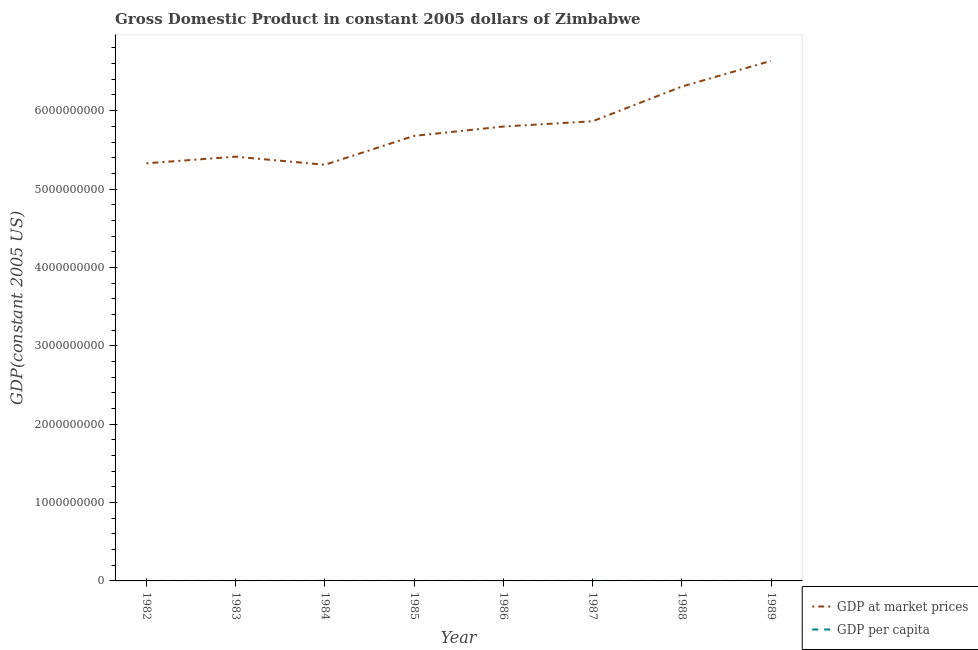What is the gdp per capita in 1984?
Keep it short and to the point. 622.59. Across all years, what is the maximum gdp per capita?
Your answer should be compact. 676.51. Across all years, what is the minimum gdp per capita?
Provide a succinct answer. 614.99. In which year was the gdp per capita maximum?
Your answer should be very brief. 1982. In which year was the gdp at market prices minimum?
Provide a short and direct response. 1984. What is the total gdp at market prices in the graph?
Your answer should be compact. 4.63e+1. What is the difference between the gdp at market prices in 1984 and that in 1985?
Your answer should be compact. -3.69e+08. What is the difference between the gdp per capita in 1988 and the gdp at market prices in 1987?
Provide a short and direct response. -5.86e+09. What is the average gdp at market prices per year?
Your answer should be compact. 5.79e+09. In the year 1984, what is the difference between the gdp per capita and gdp at market prices?
Give a very brief answer. -5.31e+09. In how many years, is the gdp per capita greater than 5600000000 US$?
Make the answer very short. 0. What is the ratio of the gdp per capita in 1983 to that in 1984?
Offer a very short reply. 1.06. Is the gdp at market prices in 1983 less than that in 1986?
Provide a short and direct response. Yes. Is the difference between the gdp at market prices in 1984 and 1988 greater than the difference between the gdp per capita in 1984 and 1988?
Your answer should be compact. No. What is the difference between the highest and the second highest gdp per capita?
Ensure brevity in your answer.  16.2. What is the difference between the highest and the lowest gdp per capita?
Give a very brief answer. 61.52. In how many years, is the gdp at market prices greater than the average gdp at market prices taken over all years?
Your answer should be compact. 4. Does the gdp at market prices monotonically increase over the years?
Your answer should be very brief. No. Is the gdp at market prices strictly greater than the gdp per capita over the years?
Offer a very short reply. Yes. Is the gdp at market prices strictly less than the gdp per capita over the years?
Offer a very short reply. No. How many years are there in the graph?
Your answer should be very brief. 8. Where does the legend appear in the graph?
Your response must be concise. Bottom right. How are the legend labels stacked?
Provide a short and direct response. Vertical. What is the title of the graph?
Ensure brevity in your answer.  Gross Domestic Product in constant 2005 dollars of Zimbabwe. Does "Goods" appear as one of the legend labels in the graph?
Provide a succinct answer. No. What is the label or title of the Y-axis?
Offer a terse response. GDP(constant 2005 US). What is the GDP(constant 2005 US) in GDP at market prices in 1982?
Offer a terse response. 5.33e+09. What is the GDP(constant 2005 US) in GDP per capita in 1982?
Your answer should be very brief. 676.51. What is the GDP(constant 2005 US) in GDP at market prices in 1983?
Provide a short and direct response. 5.41e+09. What is the GDP(constant 2005 US) of GDP per capita in 1983?
Offer a terse response. 660.31. What is the GDP(constant 2005 US) in GDP at market prices in 1984?
Offer a very short reply. 5.31e+09. What is the GDP(constant 2005 US) in GDP per capita in 1984?
Your response must be concise. 622.59. What is the GDP(constant 2005 US) of GDP at market prices in 1985?
Provide a short and direct response. 5.68e+09. What is the GDP(constant 2005 US) of GDP per capita in 1985?
Give a very brief answer. 640.72. What is the GDP(constant 2005 US) in GDP at market prices in 1986?
Give a very brief answer. 5.80e+09. What is the GDP(constant 2005 US) of GDP per capita in 1986?
Your answer should be very brief. 630.25. What is the GDP(constant 2005 US) in GDP at market prices in 1987?
Your answer should be very brief. 5.86e+09. What is the GDP(constant 2005 US) in GDP per capita in 1987?
Provide a short and direct response. 614.99. What is the GDP(constant 2005 US) in GDP at market prices in 1988?
Offer a terse response. 6.31e+09. What is the GDP(constant 2005 US) of GDP per capita in 1988?
Offer a very short reply. 639.24. What is the GDP(constant 2005 US) in GDP at market prices in 1989?
Make the answer very short. 6.64e+09. What is the GDP(constant 2005 US) of GDP per capita in 1989?
Keep it short and to the point. 651.47. Across all years, what is the maximum GDP(constant 2005 US) of GDP at market prices?
Make the answer very short. 6.64e+09. Across all years, what is the maximum GDP(constant 2005 US) in GDP per capita?
Your response must be concise. 676.51. Across all years, what is the minimum GDP(constant 2005 US) of GDP at market prices?
Your answer should be very brief. 5.31e+09. Across all years, what is the minimum GDP(constant 2005 US) in GDP per capita?
Provide a short and direct response. 614.99. What is the total GDP(constant 2005 US) of GDP at market prices in the graph?
Your response must be concise. 4.63e+1. What is the total GDP(constant 2005 US) of GDP per capita in the graph?
Give a very brief answer. 5136.07. What is the difference between the GDP(constant 2005 US) in GDP at market prices in 1982 and that in 1983?
Make the answer very short. -8.45e+07. What is the difference between the GDP(constant 2005 US) in GDP per capita in 1982 and that in 1983?
Provide a succinct answer. 16.2. What is the difference between the GDP(constant 2005 US) in GDP at market prices in 1982 and that in 1984?
Your response must be concise. 1.88e+07. What is the difference between the GDP(constant 2005 US) of GDP per capita in 1982 and that in 1984?
Your response must be concise. 53.91. What is the difference between the GDP(constant 2005 US) in GDP at market prices in 1982 and that in 1985?
Offer a terse response. -3.50e+08. What is the difference between the GDP(constant 2005 US) of GDP per capita in 1982 and that in 1985?
Ensure brevity in your answer.  35.79. What is the difference between the GDP(constant 2005 US) in GDP at market prices in 1982 and that in 1986?
Your response must be concise. -4.69e+08. What is the difference between the GDP(constant 2005 US) in GDP per capita in 1982 and that in 1986?
Make the answer very short. 46.26. What is the difference between the GDP(constant 2005 US) of GDP at market prices in 1982 and that in 1987?
Your answer should be very brief. -5.36e+08. What is the difference between the GDP(constant 2005 US) of GDP per capita in 1982 and that in 1987?
Ensure brevity in your answer.  61.52. What is the difference between the GDP(constant 2005 US) of GDP at market prices in 1982 and that in 1988?
Offer a terse response. -9.79e+08. What is the difference between the GDP(constant 2005 US) of GDP per capita in 1982 and that in 1988?
Offer a terse response. 37.27. What is the difference between the GDP(constant 2005 US) in GDP at market prices in 1982 and that in 1989?
Provide a short and direct response. -1.31e+09. What is the difference between the GDP(constant 2005 US) of GDP per capita in 1982 and that in 1989?
Ensure brevity in your answer.  25.04. What is the difference between the GDP(constant 2005 US) of GDP at market prices in 1983 and that in 1984?
Your answer should be very brief. 1.03e+08. What is the difference between the GDP(constant 2005 US) of GDP per capita in 1983 and that in 1984?
Your answer should be very brief. 37.72. What is the difference between the GDP(constant 2005 US) in GDP at market prices in 1983 and that in 1985?
Your answer should be compact. -2.65e+08. What is the difference between the GDP(constant 2005 US) in GDP per capita in 1983 and that in 1985?
Offer a terse response. 19.59. What is the difference between the GDP(constant 2005 US) of GDP at market prices in 1983 and that in 1986?
Offer a very short reply. -3.85e+08. What is the difference between the GDP(constant 2005 US) of GDP per capita in 1983 and that in 1986?
Ensure brevity in your answer.  30.06. What is the difference between the GDP(constant 2005 US) in GDP at market prices in 1983 and that in 1987?
Your answer should be compact. -4.51e+08. What is the difference between the GDP(constant 2005 US) in GDP per capita in 1983 and that in 1987?
Make the answer very short. 45.32. What is the difference between the GDP(constant 2005 US) in GDP at market prices in 1983 and that in 1988?
Offer a very short reply. -8.94e+08. What is the difference between the GDP(constant 2005 US) in GDP per capita in 1983 and that in 1988?
Your answer should be very brief. 21.07. What is the difference between the GDP(constant 2005 US) in GDP at market prices in 1983 and that in 1989?
Offer a terse response. -1.22e+09. What is the difference between the GDP(constant 2005 US) in GDP per capita in 1983 and that in 1989?
Your response must be concise. 8.84. What is the difference between the GDP(constant 2005 US) of GDP at market prices in 1984 and that in 1985?
Offer a very short reply. -3.69e+08. What is the difference between the GDP(constant 2005 US) in GDP per capita in 1984 and that in 1985?
Provide a succinct answer. -18.12. What is the difference between the GDP(constant 2005 US) of GDP at market prices in 1984 and that in 1986?
Your answer should be very brief. -4.88e+08. What is the difference between the GDP(constant 2005 US) in GDP per capita in 1984 and that in 1986?
Provide a succinct answer. -7.66. What is the difference between the GDP(constant 2005 US) of GDP at market prices in 1984 and that in 1987?
Give a very brief answer. -5.55e+08. What is the difference between the GDP(constant 2005 US) in GDP per capita in 1984 and that in 1987?
Provide a succinct answer. 7.61. What is the difference between the GDP(constant 2005 US) in GDP at market prices in 1984 and that in 1988?
Your response must be concise. -9.98e+08. What is the difference between the GDP(constant 2005 US) of GDP per capita in 1984 and that in 1988?
Make the answer very short. -16.64. What is the difference between the GDP(constant 2005 US) of GDP at market prices in 1984 and that in 1989?
Your response must be concise. -1.33e+09. What is the difference between the GDP(constant 2005 US) of GDP per capita in 1984 and that in 1989?
Your response must be concise. -28.87. What is the difference between the GDP(constant 2005 US) in GDP at market prices in 1985 and that in 1986?
Ensure brevity in your answer.  -1.19e+08. What is the difference between the GDP(constant 2005 US) of GDP per capita in 1985 and that in 1986?
Your answer should be compact. 10.46. What is the difference between the GDP(constant 2005 US) in GDP at market prices in 1985 and that in 1987?
Make the answer very short. -1.86e+08. What is the difference between the GDP(constant 2005 US) of GDP per capita in 1985 and that in 1987?
Make the answer very short. 25.73. What is the difference between the GDP(constant 2005 US) in GDP at market prices in 1985 and that in 1988?
Your response must be concise. -6.29e+08. What is the difference between the GDP(constant 2005 US) in GDP per capita in 1985 and that in 1988?
Provide a succinct answer. 1.48. What is the difference between the GDP(constant 2005 US) in GDP at market prices in 1985 and that in 1989?
Offer a terse response. -9.57e+08. What is the difference between the GDP(constant 2005 US) of GDP per capita in 1985 and that in 1989?
Ensure brevity in your answer.  -10.75. What is the difference between the GDP(constant 2005 US) in GDP at market prices in 1986 and that in 1987?
Make the answer very short. -6.67e+07. What is the difference between the GDP(constant 2005 US) of GDP per capita in 1986 and that in 1987?
Ensure brevity in your answer.  15.26. What is the difference between the GDP(constant 2005 US) of GDP at market prices in 1986 and that in 1988?
Offer a very short reply. -5.10e+08. What is the difference between the GDP(constant 2005 US) in GDP per capita in 1986 and that in 1988?
Give a very brief answer. -8.99. What is the difference between the GDP(constant 2005 US) in GDP at market prices in 1986 and that in 1989?
Provide a succinct answer. -8.38e+08. What is the difference between the GDP(constant 2005 US) in GDP per capita in 1986 and that in 1989?
Offer a terse response. -21.22. What is the difference between the GDP(constant 2005 US) in GDP at market prices in 1987 and that in 1988?
Make the answer very short. -4.43e+08. What is the difference between the GDP(constant 2005 US) in GDP per capita in 1987 and that in 1988?
Keep it short and to the point. -24.25. What is the difference between the GDP(constant 2005 US) of GDP at market prices in 1987 and that in 1989?
Provide a succinct answer. -7.71e+08. What is the difference between the GDP(constant 2005 US) of GDP per capita in 1987 and that in 1989?
Keep it short and to the point. -36.48. What is the difference between the GDP(constant 2005 US) in GDP at market prices in 1988 and that in 1989?
Offer a terse response. -3.28e+08. What is the difference between the GDP(constant 2005 US) in GDP per capita in 1988 and that in 1989?
Give a very brief answer. -12.23. What is the difference between the GDP(constant 2005 US) of GDP at market prices in 1982 and the GDP(constant 2005 US) of GDP per capita in 1983?
Make the answer very short. 5.33e+09. What is the difference between the GDP(constant 2005 US) in GDP at market prices in 1982 and the GDP(constant 2005 US) in GDP per capita in 1984?
Give a very brief answer. 5.33e+09. What is the difference between the GDP(constant 2005 US) of GDP at market prices in 1982 and the GDP(constant 2005 US) of GDP per capita in 1985?
Ensure brevity in your answer.  5.33e+09. What is the difference between the GDP(constant 2005 US) of GDP at market prices in 1982 and the GDP(constant 2005 US) of GDP per capita in 1986?
Keep it short and to the point. 5.33e+09. What is the difference between the GDP(constant 2005 US) in GDP at market prices in 1982 and the GDP(constant 2005 US) in GDP per capita in 1987?
Make the answer very short. 5.33e+09. What is the difference between the GDP(constant 2005 US) in GDP at market prices in 1982 and the GDP(constant 2005 US) in GDP per capita in 1988?
Your response must be concise. 5.33e+09. What is the difference between the GDP(constant 2005 US) in GDP at market prices in 1982 and the GDP(constant 2005 US) in GDP per capita in 1989?
Your answer should be compact. 5.33e+09. What is the difference between the GDP(constant 2005 US) in GDP at market prices in 1983 and the GDP(constant 2005 US) in GDP per capita in 1984?
Offer a terse response. 5.41e+09. What is the difference between the GDP(constant 2005 US) of GDP at market prices in 1983 and the GDP(constant 2005 US) of GDP per capita in 1985?
Ensure brevity in your answer.  5.41e+09. What is the difference between the GDP(constant 2005 US) in GDP at market prices in 1983 and the GDP(constant 2005 US) in GDP per capita in 1986?
Offer a very short reply. 5.41e+09. What is the difference between the GDP(constant 2005 US) in GDP at market prices in 1983 and the GDP(constant 2005 US) in GDP per capita in 1987?
Ensure brevity in your answer.  5.41e+09. What is the difference between the GDP(constant 2005 US) in GDP at market prices in 1983 and the GDP(constant 2005 US) in GDP per capita in 1988?
Your response must be concise. 5.41e+09. What is the difference between the GDP(constant 2005 US) of GDP at market prices in 1983 and the GDP(constant 2005 US) of GDP per capita in 1989?
Your answer should be compact. 5.41e+09. What is the difference between the GDP(constant 2005 US) of GDP at market prices in 1984 and the GDP(constant 2005 US) of GDP per capita in 1985?
Provide a short and direct response. 5.31e+09. What is the difference between the GDP(constant 2005 US) in GDP at market prices in 1984 and the GDP(constant 2005 US) in GDP per capita in 1986?
Provide a short and direct response. 5.31e+09. What is the difference between the GDP(constant 2005 US) of GDP at market prices in 1984 and the GDP(constant 2005 US) of GDP per capita in 1987?
Your response must be concise. 5.31e+09. What is the difference between the GDP(constant 2005 US) in GDP at market prices in 1984 and the GDP(constant 2005 US) in GDP per capita in 1988?
Provide a succinct answer. 5.31e+09. What is the difference between the GDP(constant 2005 US) in GDP at market prices in 1984 and the GDP(constant 2005 US) in GDP per capita in 1989?
Your answer should be compact. 5.31e+09. What is the difference between the GDP(constant 2005 US) of GDP at market prices in 1985 and the GDP(constant 2005 US) of GDP per capita in 1986?
Your answer should be compact. 5.68e+09. What is the difference between the GDP(constant 2005 US) in GDP at market prices in 1985 and the GDP(constant 2005 US) in GDP per capita in 1987?
Provide a short and direct response. 5.68e+09. What is the difference between the GDP(constant 2005 US) in GDP at market prices in 1985 and the GDP(constant 2005 US) in GDP per capita in 1988?
Offer a very short reply. 5.68e+09. What is the difference between the GDP(constant 2005 US) of GDP at market prices in 1985 and the GDP(constant 2005 US) of GDP per capita in 1989?
Make the answer very short. 5.68e+09. What is the difference between the GDP(constant 2005 US) of GDP at market prices in 1986 and the GDP(constant 2005 US) of GDP per capita in 1987?
Your answer should be compact. 5.80e+09. What is the difference between the GDP(constant 2005 US) in GDP at market prices in 1986 and the GDP(constant 2005 US) in GDP per capita in 1988?
Your response must be concise. 5.80e+09. What is the difference between the GDP(constant 2005 US) in GDP at market prices in 1986 and the GDP(constant 2005 US) in GDP per capita in 1989?
Your answer should be very brief. 5.80e+09. What is the difference between the GDP(constant 2005 US) in GDP at market prices in 1987 and the GDP(constant 2005 US) in GDP per capita in 1988?
Offer a very short reply. 5.86e+09. What is the difference between the GDP(constant 2005 US) of GDP at market prices in 1987 and the GDP(constant 2005 US) of GDP per capita in 1989?
Make the answer very short. 5.86e+09. What is the difference between the GDP(constant 2005 US) of GDP at market prices in 1988 and the GDP(constant 2005 US) of GDP per capita in 1989?
Offer a very short reply. 6.31e+09. What is the average GDP(constant 2005 US) in GDP at market prices per year?
Ensure brevity in your answer.  5.79e+09. What is the average GDP(constant 2005 US) of GDP per capita per year?
Offer a very short reply. 642.01. In the year 1982, what is the difference between the GDP(constant 2005 US) in GDP at market prices and GDP(constant 2005 US) in GDP per capita?
Your answer should be very brief. 5.33e+09. In the year 1983, what is the difference between the GDP(constant 2005 US) of GDP at market prices and GDP(constant 2005 US) of GDP per capita?
Give a very brief answer. 5.41e+09. In the year 1984, what is the difference between the GDP(constant 2005 US) in GDP at market prices and GDP(constant 2005 US) in GDP per capita?
Offer a terse response. 5.31e+09. In the year 1985, what is the difference between the GDP(constant 2005 US) of GDP at market prices and GDP(constant 2005 US) of GDP per capita?
Provide a short and direct response. 5.68e+09. In the year 1986, what is the difference between the GDP(constant 2005 US) in GDP at market prices and GDP(constant 2005 US) in GDP per capita?
Offer a very short reply. 5.80e+09. In the year 1987, what is the difference between the GDP(constant 2005 US) of GDP at market prices and GDP(constant 2005 US) of GDP per capita?
Your answer should be compact. 5.86e+09. In the year 1988, what is the difference between the GDP(constant 2005 US) in GDP at market prices and GDP(constant 2005 US) in GDP per capita?
Ensure brevity in your answer.  6.31e+09. In the year 1989, what is the difference between the GDP(constant 2005 US) in GDP at market prices and GDP(constant 2005 US) in GDP per capita?
Provide a succinct answer. 6.64e+09. What is the ratio of the GDP(constant 2005 US) of GDP at market prices in 1982 to that in 1983?
Offer a terse response. 0.98. What is the ratio of the GDP(constant 2005 US) in GDP per capita in 1982 to that in 1983?
Your answer should be very brief. 1.02. What is the ratio of the GDP(constant 2005 US) of GDP per capita in 1982 to that in 1984?
Your answer should be compact. 1.09. What is the ratio of the GDP(constant 2005 US) of GDP at market prices in 1982 to that in 1985?
Offer a very short reply. 0.94. What is the ratio of the GDP(constant 2005 US) in GDP per capita in 1982 to that in 1985?
Offer a very short reply. 1.06. What is the ratio of the GDP(constant 2005 US) in GDP at market prices in 1982 to that in 1986?
Your answer should be very brief. 0.92. What is the ratio of the GDP(constant 2005 US) in GDP per capita in 1982 to that in 1986?
Your answer should be compact. 1.07. What is the ratio of the GDP(constant 2005 US) in GDP at market prices in 1982 to that in 1987?
Your answer should be very brief. 0.91. What is the ratio of the GDP(constant 2005 US) in GDP per capita in 1982 to that in 1987?
Ensure brevity in your answer.  1.1. What is the ratio of the GDP(constant 2005 US) in GDP at market prices in 1982 to that in 1988?
Your answer should be very brief. 0.84. What is the ratio of the GDP(constant 2005 US) of GDP per capita in 1982 to that in 1988?
Your answer should be compact. 1.06. What is the ratio of the GDP(constant 2005 US) of GDP at market prices in 1982 to that in 1989?
Provide a short and direct response. 0.8. What is the ratio of the GDP(constant 2005 US) of GDP per capita in 1982 to that in 1989?
Provide a succinct answer. 1.04. What is the ratio of the GDP(constant 2005 US) of GDP at market prices in 1983 to that in 1984?
Give a very brief answer. 1.02. What is the ratio of the GDP(constant 2005 US) in GDP per capita in 1983 to that in 1984?
Provide a short and direct response. 1.06. What is the ratio of the GDP(constant 2005 US) of GDP at market prices in 1983 to that in 1985?
Offer a very short reply. 0.95. What is the ratio of the GDP(constant 2005 US) of GDP per capita in 1983 to that in 1985?
Your answer should be compact. 1.03. What is the ratio of the GDP(constant 2005 US) in GDP at market prices in 1983 to that in 1986?
Give a very brief answer. 0.93. What is the ratio of the GDP(constant 2005 US) of GDP per capita in 1983 to that in 1986?
Offer a terse response. 1.05. What is the ratio of the GDP(constant 2005 US) of GDP at market prices in 1983 to that in 1987?
Ensure brevity in your answer.  0.92. What is the ratio of the GDP(constant 2005 US) in GDP per capita in 1983 to that in 1987?
Make the answer very short. 1.07. What is the ratio of the GDP(constant 2005 US) of GDP at market prices in 1983 to that in 1988?
Your answer should be compact. 0.86. What is the ratio of the GDP(constant 2005 US) in GDP per capita in 1983 to that in 1988?
Provide a succinct answer. 1.03. What is the ratio of the GDP(constant 2005 US) in GDP at market prices in 1983 to that in 1989?
Offer a terse response. 0.82. What is the ratio of the GDP(constant 2005 US) of GDP per capita in 1983 to that in 1989?
Provide a succinct answer. 1.01. What is the ratio of the GDP(constant 2005 US) of GDP at market prices in 1984 to that in 1985?
Offer a terse response. 0.94. What is the ratio of the GDP(constant 2005 US) of GDP per capita in 1984 to that in 1985?
Provide a succinct answer. 0.97. What is the ratio of the GDP(constant 2005 US) in GDP at market prices in 1984 to that in 1986?
Make the answer very short. 0.92. What is the ratio of the GDP(constant 2005 US) of GDP per capita in 1984 to that in 1986?
Your answer should be very brief. 0.99. What is the ratio of the GDP(constant 2005 US) of GDP at market prices in 1984 to that in 1987?
Offer a terse response. 0.91. What is the ratio of the GDP(constant 2005 US) of GDP per capita in 1984 to that in 1987?
Offer a very short reply. 1.01. What is the ratio of the GDP(constant 2005 US) of GDP at market prices in 1984 to that in 1988?
Provide a succinct answer. 0.84. What is the ratio of the GDP(constant 2005 US) in GDP per capita in 1984 to that in 1988?
Give a very brief answer. 0.97. What is the ratio of the GDP(constant 2005 US) of GDP at market prices in 1984 to that in 1989?
Your answer should be compact. 0.8. What is the ratio of the GDP(constant 2005 US) in GDP per capita in 1984 to that in 1989?
Ensure brevity in your answer.  0.96. What is the ratio of the GDP(constant 2005 US) in GDP at market prices in 1985 to that in 1986?
Give a very brief answer. 0.98. What is the ratio of the GDP(constant 2005 US) of GDP per capita in 1985 to that in 1986?
Your answer should be compact. 1.02. What is the ratio of the GDP(constant 2005 US) of GDP at market prices in 1985 to that in 1987?
Offer a very short reply. 0.97. What is the ratio of the GDP(constant 2005 US) of GDP per capita in 1985 to that in 1987?
Provide a short and direct response. 1.04. What is the ratio of the GDP(constant 2005 US) in GDP at market prices in 1985 to that in 1988?
Your answer should be compact. 0.9. What is the ratio of the GDP(constant 2005 US) of GDP per capita in 1985 to that in 1988?
Keep it short and to the point. 1. What is the ratio of the GDP(constant 2005 US) of GDP at market prices in 1985 to that in 1989?
Ensure brevity in your answer.  0.86. What is the ratio of the GDP(constant 2005 US) of GDP per capita in 1985 to that in 1989?
Your answer should be compact. 0.98. What is the ratio of the GDP(constant 2005 US) in GDP at market prices in 1986 to that in 1987?
Your answer should be very brief. 0.99. What is the ratio of the GDP(constant 2005 US) of GDP per capita in 1986 to that in 1987?
Give a very brief answer. 1.02. What is the ratio of the GDP(constant 2005 US) in GDP at market prices in 1986 to that in 1988?
Give a very brief answer. 0.92. What is the ratio of the GDP(constant 2005 US) in GDP per capita in 1986 to that in 1988?
Offer a terse response. 0.99. What is the ratio of the GDP(constant 2005 US) in GDP at market prices in 1986 to that in 1989?
Ensure brevity in your answer.  0.87. What is the ratio of the GDP(constant 2005 US) in GDP per capita in 1986 to that in 1989?
Offer a terse response. 0.97. What is the ratio of the GDP(constant 2005 US) in GDP at market prices in 1987 to that in 1988?
Provide a succinct answer. 0.93. What is the ratio of the GDP(constant 2005 US) of GDP per capita in 1987 to that in 1988?
Your response must be concise. 0.96. What is the ratio of the GDP(constant 2005 US) of GDP at market prices in 1987 to that in 1989?
Offer a terse response. 0.88. What is the ratio of the GDP(constant 2005 US) of GDP per capita in 1987 to that in 1989?
Make the answer very short. 0.94. What is the ratio of the GDP(constant 2005 US) in GDP at market prices in 1988 to that in 1989?
Provide a short and direct response. 0.95. What is the ratio of the GDP(constant 2005 US) in GDP per capita in 1988 to that in 1989?
Make the answer very short. 0.98. What is the difference between the highest and the second highest GDP(constant 2005 US) of GDP at market prices?
Make the answer very short. 3.28e+08. What is the difference between the highest and the second highest GDP(constant 2005 US) of GDP per capita?
Provide a succinct answer. 16.2. What is the difference between the highest and the lowest GDP(constant 2005 US) in GDP at market prices?
Ensure brevity in your answer.  1.33e+09. What is the difference between the highest and the lowest GDP(constant 2005 US) of GDP per capita?
Provide a succinct answer. 61.52. 